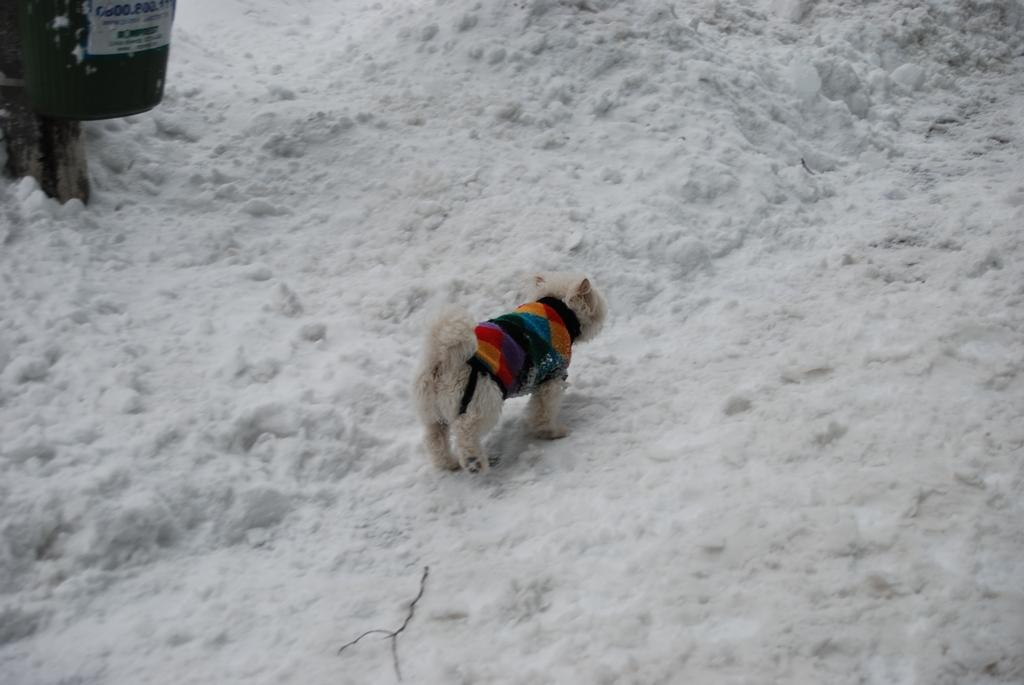What type of animal is in the image? There is a dog in the image. What is the dog doing in the image? The dog is standing on the ground. What is the condition of the ground in the image? There is snow on the ground. What type of glue is the dog using to stick to the ground in the image? There is no glue present in the image, and the dog is not using any glue to stick to the ground. 